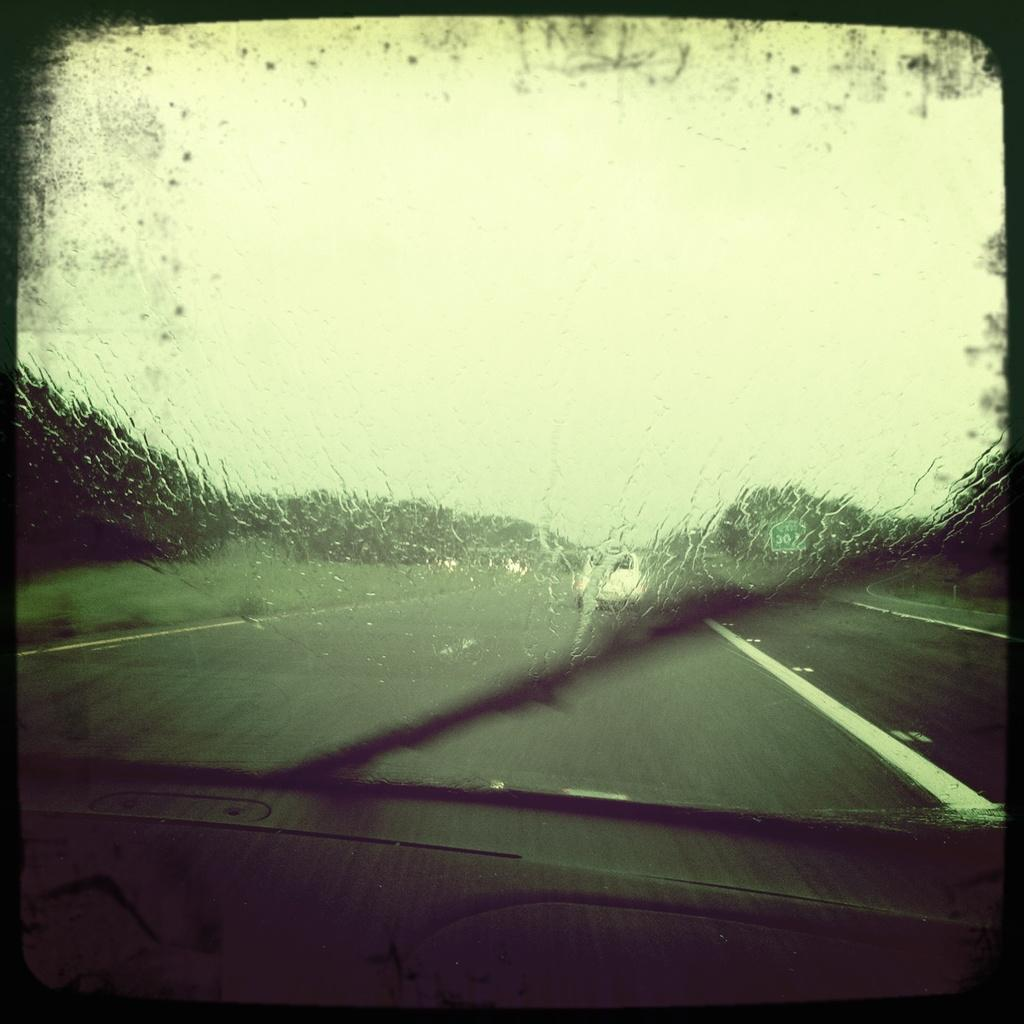What is the main feature of the image? There is a vehicle windshield in the image. What can be seen through the windshield? A windshield wiper is visible through the windshield. Where is the vehicle located? The vehicle is on the road. What type of vegetation is present in the image? There are trees in the image. What other object can be seen in the image? There is a board in the image. What is visible in the background of the image? The sky is visible in the image. How many light bulbs are hanging from the trees in the image? There are no light bulbs present in the image; it only features trees, a vehicle windshield, a windshield wiper, a board, and the sky. 